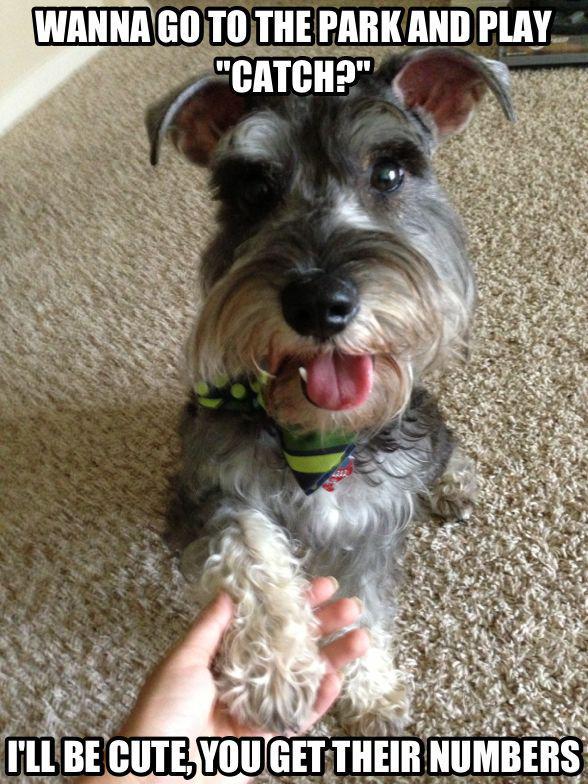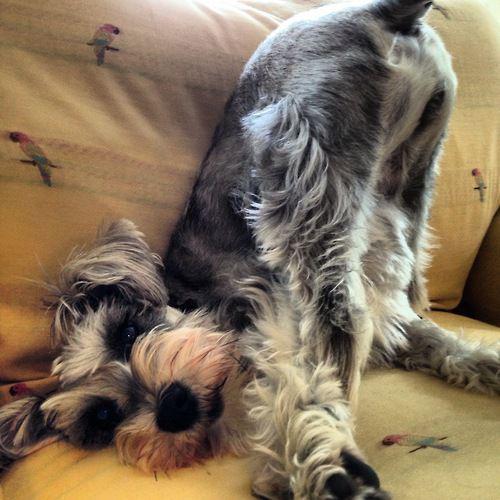The first image is the image on the left, the second image is the image on the right. For the images shown, is this caption "The dog in the image on the right is standing on two legs." true? Answer yes or no. No. The first image is the image on the left, the second image is the image on the right. For the images displayed, is the sentence "At least one schnauzer is in front of a white wall in a balancing upright pose, with its front paws not supported by anything." factually correct? Answer yes or no. No. 